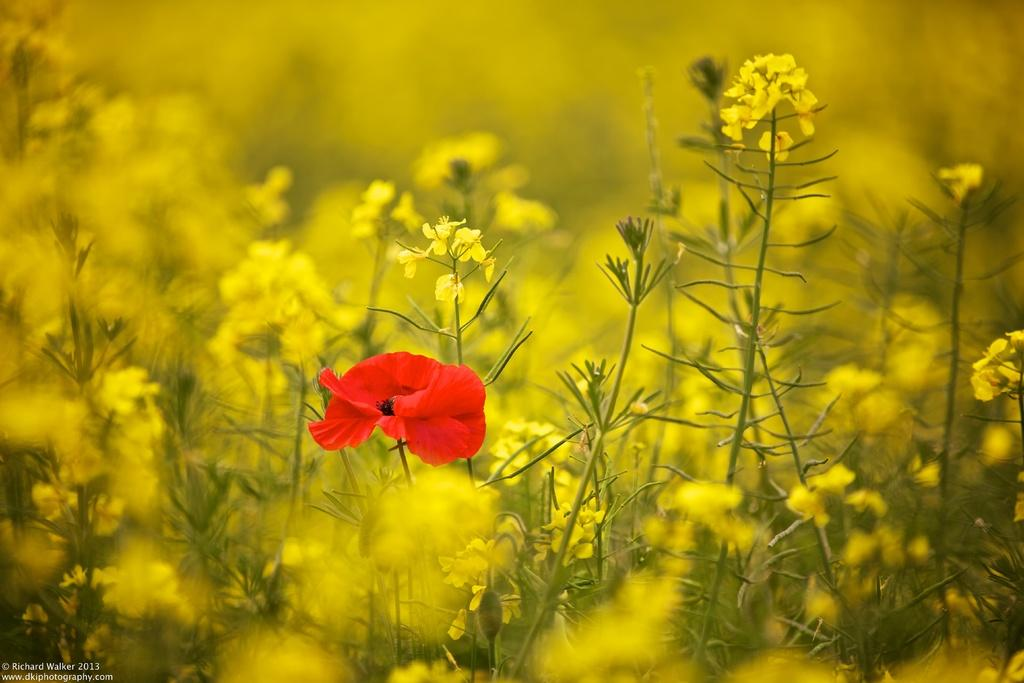What type of plants can be seen in the image? There are plants with flowers in the image. What color are the flowers on the plants? The flowers are in yellow color. Can you describe the central flower in the image? There is a red flower in the center of the image. What type of sweater is the person wearing in the image? There is no person or sweater present in the image; it features plants with flowers. 